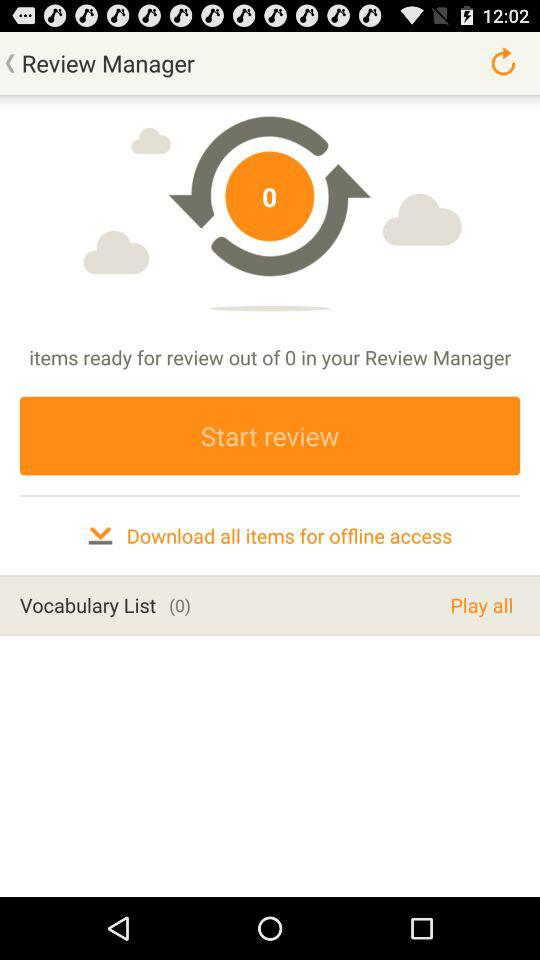How many items are there for review? There are 0 items for review. 